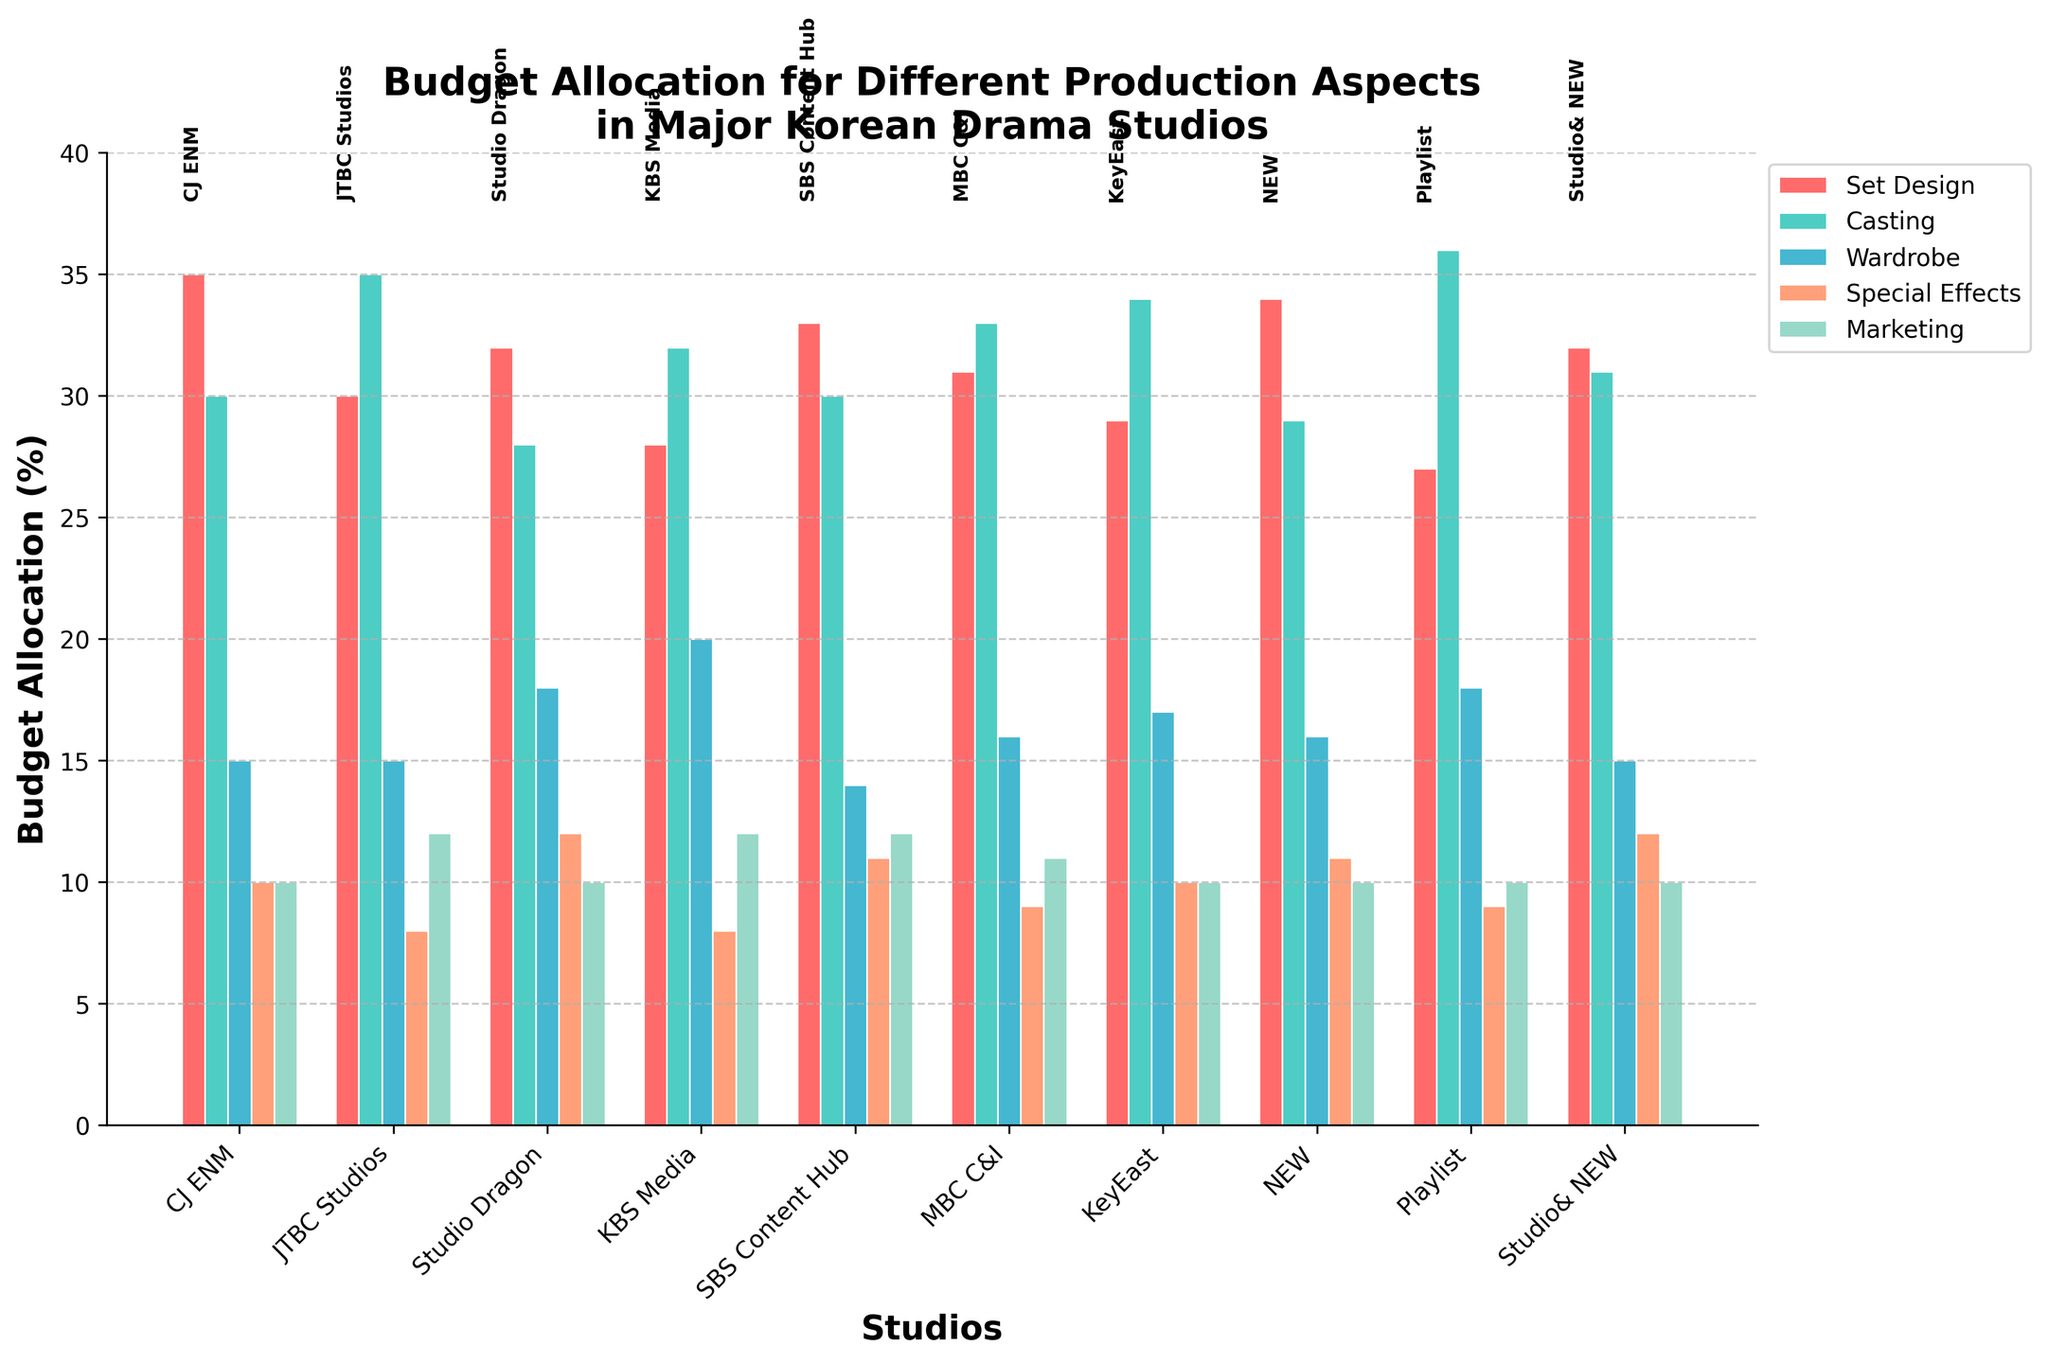Which studio allocates the highest percentage of its budget to Casting? The bar for Casting shows the highest percentage of budget allocation for Playlist Studio, colored in green.
Answer: Playlist Comparing Set Design budgets, which studio spends more: Studio Dragon or JTBC Studios? The bar indicating Set Design is taller for Studio Dragon (32%) compared to JTBC Studios (30%).
Answer: Studio Dragon What's the total budget allocation for Special Effects across all studios? Sum the percentages allocated to Special Effects for each studio: 10 + 8 + 12 + 8 + 11 + 9 + 10 + 11 + 9 + 12 = 100.
Answer: 100% Which studio has the closest budget allocation for Marketing and Special Effects? Comparing the lengths visually, KBS Media has both Marketing and Special Effects at 12%, and few other studios show such a close match.
Answer: KBS Media What is the average percentage allocation to Wardrobe across all studios? Sum the Wardrobe percentages and divide by the number of studios: (15+15+18+20+14+16+17+16+18+15)/10 = 16.4.
Answer: 16.4% Is there a studio that allocates an equal percentage to Set Design and Casting? Visually compare, only CJ ENM allocates a percentage (35%) to Set Design and Casting that do not match the values of other studios.
Answer: No Which studio has the smallest allocation for Set Design, and what is the value? The smallest allocation for Set Design is visually Playlist Studio, and the height corresponds to 27%.
Answer: Playlist, 27% If you sum the budgets for Set Design and Wardrobe of SBS Content Hub, what's the combined percentage? Visually tally the bar heights: Set Design (33%) + Wardrobe (14%) means 33 + 14 = 47.
Answer: 47% Between MBC C&I and KeyEast, which studio allocates a higher total percentage to Wardrobe and Marketing? Summing up MBC C&I's Wardrobe and Marketing (16% + 11% = 27%) and KeyEast's (17% + 10% = 27%) shows both have the same allocation.
Answer: Both equal What's the median percentage allocation for Special Effects among the studios? Sorting the percentage allocations for Special Effects: 8, 8, 9, 9, 10, 10, 11, 11, 12, 12 - the middle values are 10 and 10, their median is 10.
Answer: 10% 